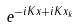<formula> <loc_0><loc_0><loc_500><loc_500>e ^ { - i K x + i K x _ { k } }</formula> 